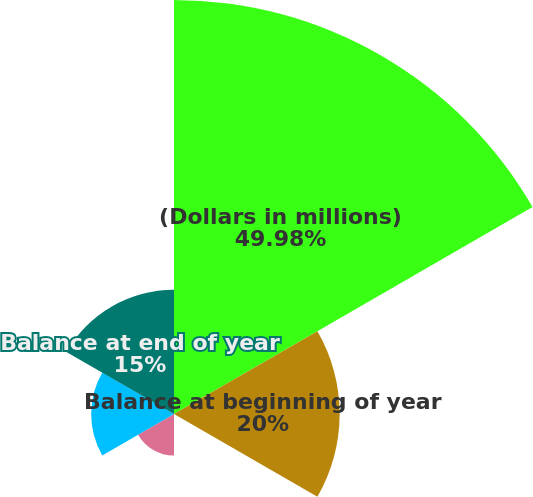Convert chart. <chart><loc_0><loc_0><loc_500><loc_500><pie_chart><fcel>(Dollars in millions)<fcel>Balance at beginning of year<fcel>Liabilities assumed<fcel>Adjustments to reserves<fcel>Benefits paid in the current<fcel>Balance at end of year<nl><fcel>49.99%<fcel>20.0%<fcel>0.01%<fcel>5.01%<fcel>10.0%<fcel>15.0%<nl></chart> 